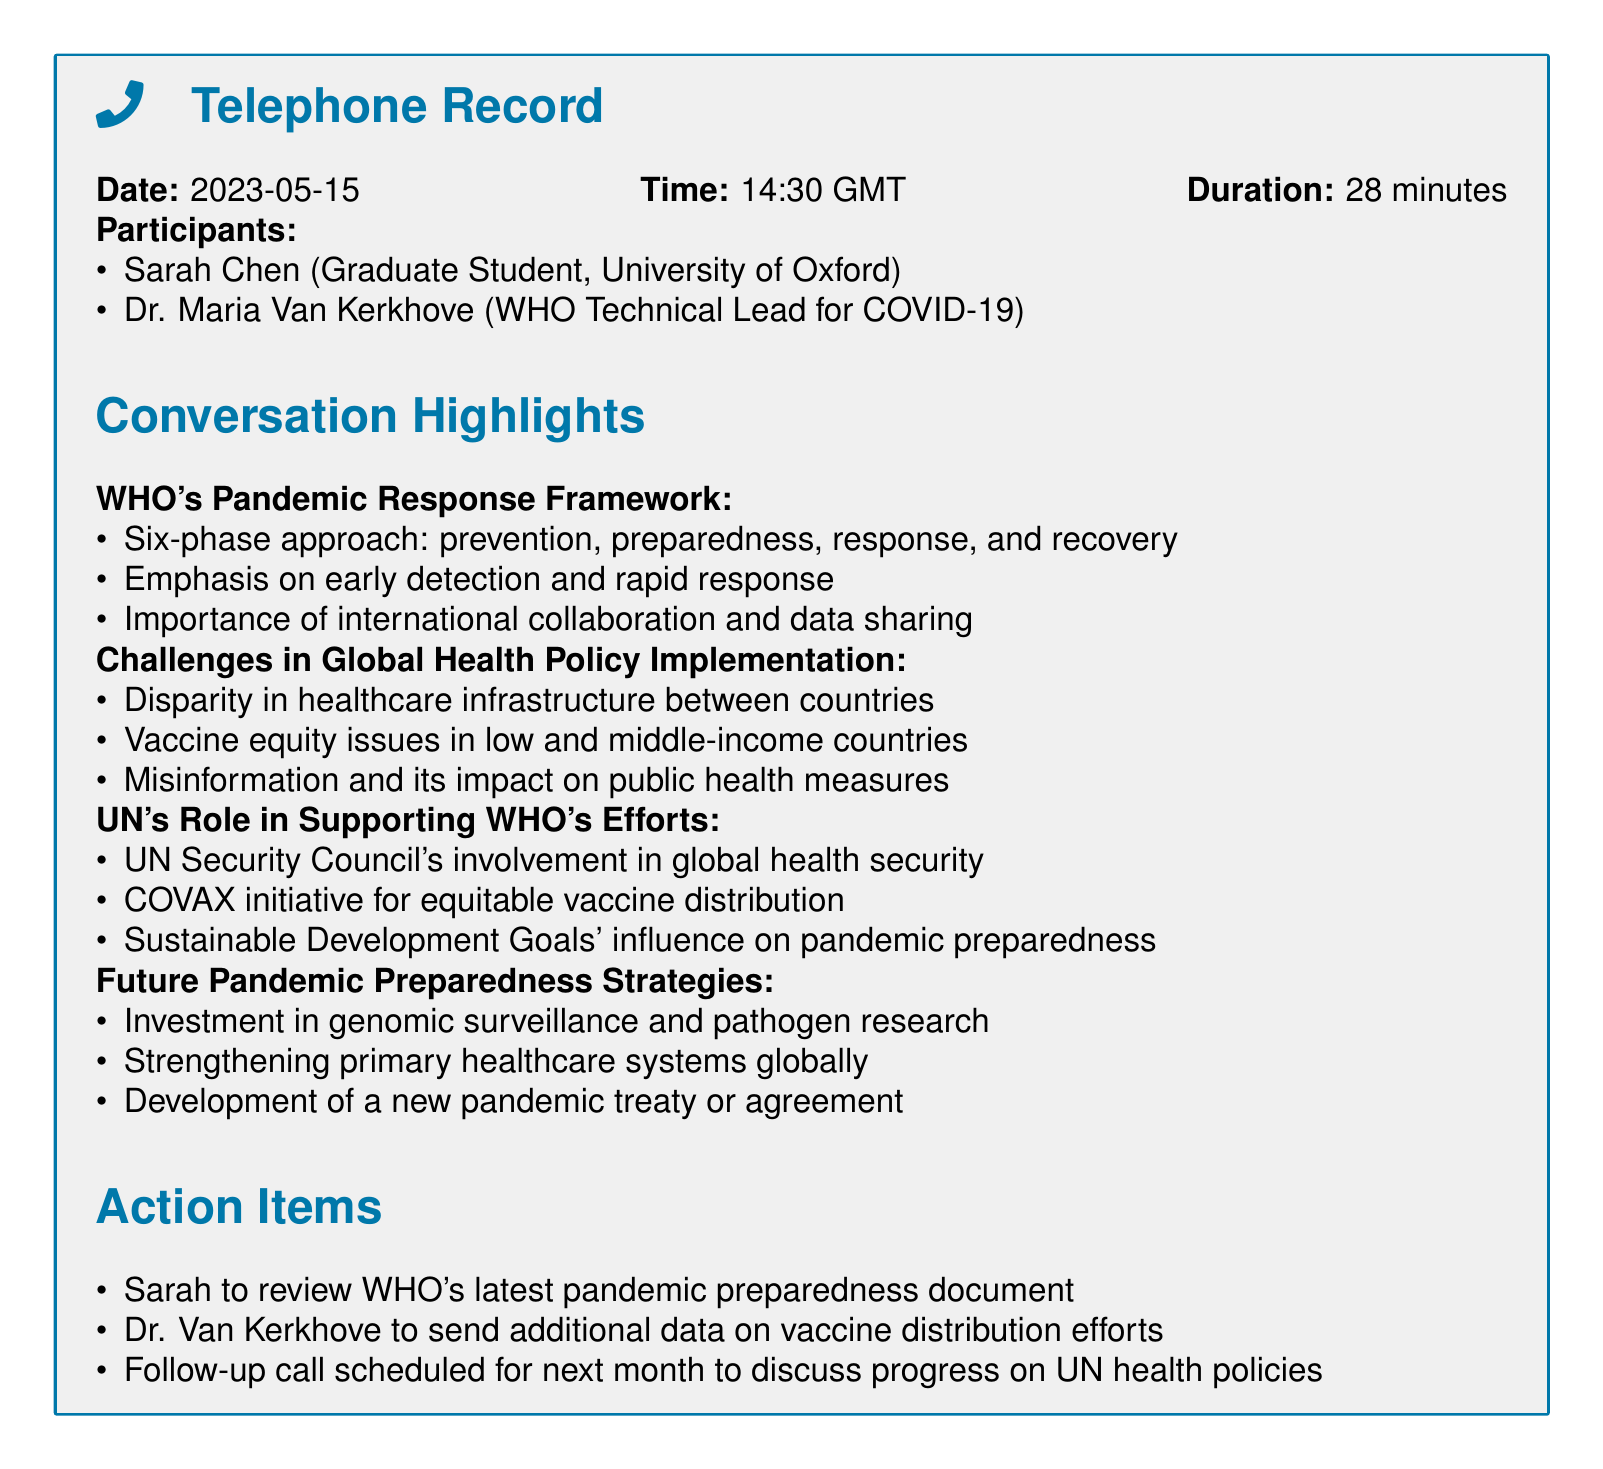What is the date of the call? The date is explicitly mentioned in the document as "2023-05-15".
Answer: 2023-05-15 Who is the WHO Technical Lead for COVID-19? Dr. Maria Van Kerkhove is specifically identified as the WHO Technical Lead for COVID-19 in the participant list.
Answer: Dr. Maria Van Kerkhove What is the duration of the conversation? The document states that the duration of the call is "28 minutes".
Answer: 28 minutes What initiative is mentioned for equitable vaccine distribution? The document refers to the "COVAX initiative" that supports equitable vaccine distribution.
Answer: COVAX initiative What is one of the challenges mentioned regarding vaccine distribution? The document highlights "vaccine equity issues in low and middle-income countries" as a challenge.
Answer: Vaccine equity issues in low and middle-income countries What is one action item for Sarah? One of the action items explicitly states that Sarah is to "review WHO's latest pandemic preparedness document".
Answer: Review WHO's latest pandemic preparedness document What phase of the pandemic response framework emphasizes early detection? The "preparedness" phase emphasizes early detection as part of WHO's pandemic response framework.
Answer: Preparedness What does the WHO emphasize regarding global collaboration? The document states the "importance of international collaboration and data sharing" in the context of pandemic response.
Answer: Importance of international collaboration and data sharing What future strategy involves genomic surveillance? The document mentions "investment in genomic surveillance and pathogen research" as a future pandemic preparedness strategy.
Answer: Investment in genomic surveillance and pathogen research 